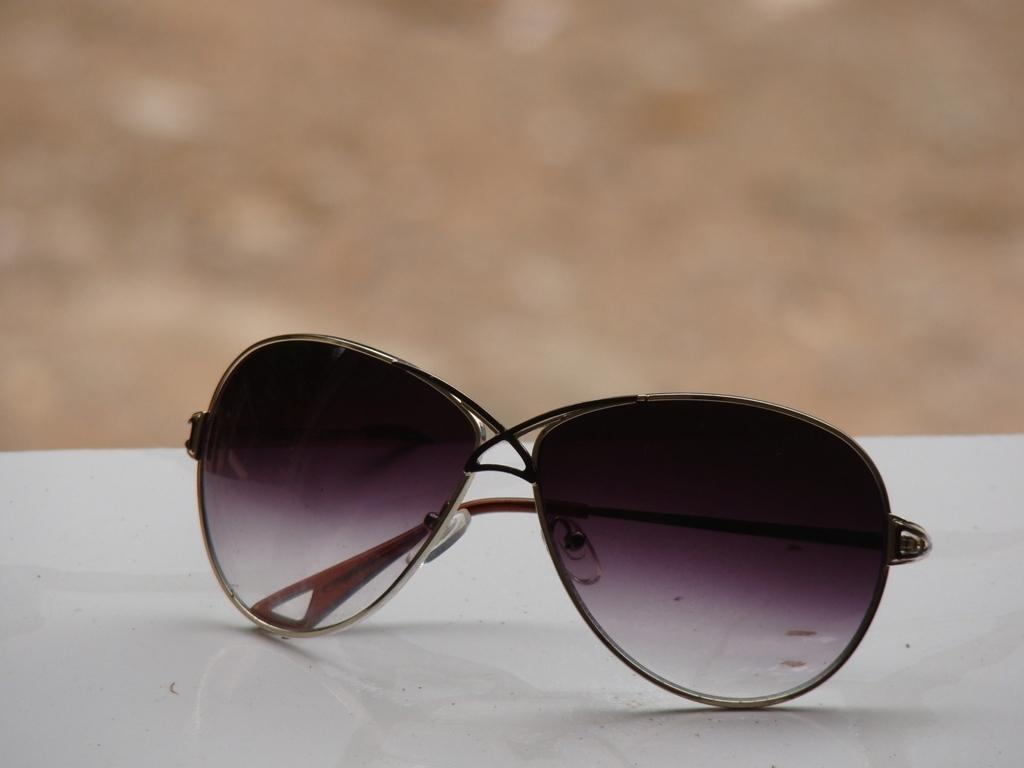What is the main subject of the image? There is a spectacle in the image. What is the color of the surface on which the spectacle is placed? The spectacle is on a white surface. Can you describe the background of the image? The background of the image is blurred. How many chickens are participating in the event depicted in the image? There is no event or chickens present in the image; it features a spectacle on a white surface with a blurred background. 